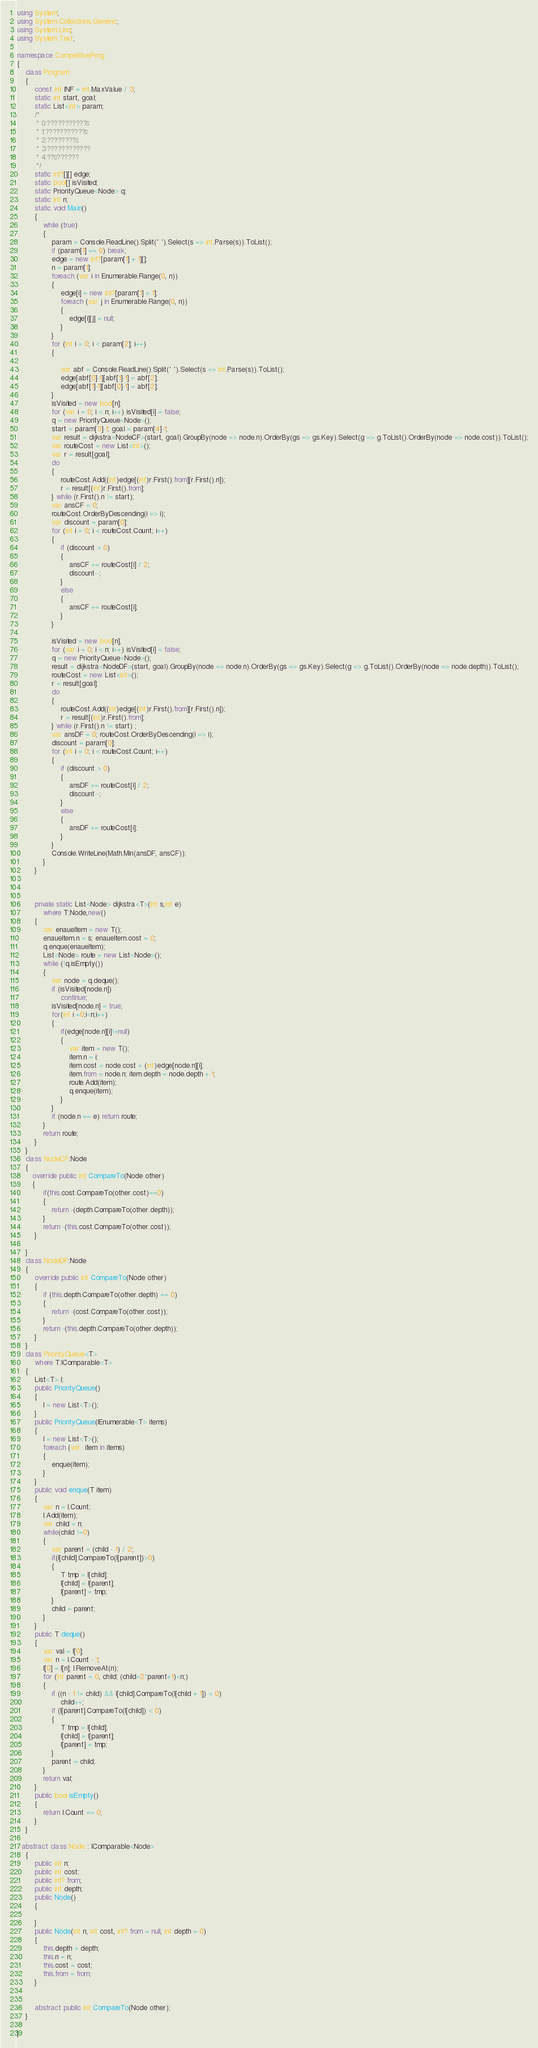<code> <loc_0><loc_0><loc_500><loc_500><_C#_>using System;
using System.Collections.Generic;
using System.Linq;
using System.Text;

namespace CompetitiveProg
{
    class Program
    {
        const int INF = int.MaxValue / 3;
        static int start, goal;
        static List<int> param;
        /*
         * 0:???????????°
         * 1:???????????°
         * 2:????????°
         * 3:????????????
         * 4:??´??????
         */
        static int?[][] edge;
        static bool[] isVisited;
        static PriorityQueue<Node> q;
        static int n;
        static void Main()
        {
            while (true)
            {
                param = Console.ReadLine().Split(' ').Select(s => int.Parse(s)).ToList();
                if (param[1] == 0) break;
                edge = new int?[param[1] + 1][];
                n = param[1];
                foreach (var i in Enumerable.Range(0, n))
                {
                    edge[i] = new int?[param[1] + 1];
                    foreach (var j in Enumerable.Range(0, n))
                    {
                        edge[i][j] = null;
                    }
                }
                for (int i = 0; i < param[2]; i++)
                {

                    var abf = Console.ReadLine().Split(' ').Select(s => int.Parse(s)).ToList();
                    edge[abf[0]-1][abf[1]-1] = abf[2];
                    edge[abf[1]-1][abf[0]-1] = abf[2];
                }
                isVisited = new bool[n];
                for (var i = 0; i < n; i++) isVisited[i] = false;
                q = new PriorityQueue<Node>();
                start = param[3]-1; goal = param[4]-1;
                var result = dijkstra<NodeCF>(start, goal).GroupBy(node => node.n).OrderBy(gs => gs.Key).Select(g => g.ToList().OrderBy(node => node.cost)).ToList();
                var routeCost = new List<int>();
                var r = result[goal];
                do
                {
                    routeCost.Add((int)edge[(int)r.First().from][r.First().n]);
                    r = result[(int)r.First().from];
                } while (r.First().n != start);
                var ansCF = 0; 
                routeCost.OrderByDescending(i => i);
                var discount = param[0];
                for (int i = 0; i < routeCost.Count; i++)
                {
                    if (discount > 0)
                    {
                        ansCF += routeCost[i] / 2;
                        discount--;
                    }
                    else
                    {
                        ansCF += routeCost[i];
                    }
                }

                isVisited = new bool[n];
                for (var i = 0; i < n; i++) isVisited[i] = false;
                q = new PriorityQueue<Node>();
                result = dijkstra<NodeDF>(start, goal).GroupBy(node => node.n).OrderBy(gs => gs.Key).Select(g => g.ToList().OrderBy(node => node.depth)).ToList();
                routeCost = new List<int>();
                r = result[goal];
                do
                {
                    routeCost.Add((int)edge[(int)r.First().from][r.First().n]);
                    r = result[(int)r.First().from];
                } while (r.First().n != start) ;
                var ansDF = 0; routeCost.OrderByDescending(i => i);
                discount = param[0];
                for (int i = 0; i < routeCost.Count; i++)
                {
                    if (discount > 0)
                    {
                        ansDF += routeCost[i] / 2;
                        discount--;
                    }
                    else
                    {
                        ansDF += routeCost[i];
                    }
                }
                Console.WriteLine(Math.Min(ansDF, ansCF));
            }
        }
            


        private static List<Node> dijkstra<T>(int s,int e)
            where T:Node,new()
        {
            var enaueItem = new T();
            enaueItem.n = s; enaueItem.cost = 0;
            q.enque(enaueItem);
            List<Node> route = new List<Node>();
            while (!q.isEmpty())
            {
                var node = q.deque();
                if (isVisited[node.n]) 
                    continue;
                isVisited[node.n] = true;
                for(int i =0;i<n;i++)
                {
                    if(edge[node.n][i]!=null)
                    {
                        var item = new T();
                        item.n = i; 
                        item.cost = node.cost + (int)edge[node.n][i];
                        item.from = node.n; item.depth = node.depth + 1;
                        route.Add(item);
                        q.enque(item);
                    }
                }
                if (node.n == e) return route;
            }
            return route;
        }
    }
    class NodeCF:Node
    {
       override public int CompareTo(Node other)
       {
            if(this.cost.CompareTo(other.cost)==0)
            {
                return -(depth.CompareTo(other.depth));
            }
            return -(this.cost.CompareTo(other.cost));
        }

    }
    class NodeDF:Node
    {
        override public int CompareTo(Node other)
        {
            if (this.depth.CompareTo(other.depth) == 0)
            {
                return -(cost.CompareTo(other.cost));
            }
            return -(this.depth.CompareTo(other.depth));
        }
    }
    class PriorityQueue<T>
        where T:IComparable<T>
    {
        List<T> l;
        public PriorityQueue()
        {
            l = new List<T>();
        }
        public PriorityQueue(IEnumerable<T> items)
        {
            l = new List<T>();
            foreach (var  item in items)
            {
                enque(item);
            }
        }
        public void enque(T item)
        {
            var n = l.Count;
            l.Add(item);
            var child = n;
            while(child !=0)
            {
                var parent = (child - 1) / 2;
                if(l[child].CompareTo(l[parent])>0)
                {
                    T tmp = l[child];
                    l[child] = l[parent];
                    l[parent] = tmp;
                }
                child = parent;
            }
        }
        public T deque()
        {
            var val = l[0];
            var n = l.Count - 1;
            l[0] = l[n]; l.RemoveAt(n);
            for (int parent = 0, child; (child=2*parent+1)<n;)
            {
                if ((n - 1 != child) && l[child].CompareTo(l[child + 1]) < 0)
                    child++;
                if (l[parent].CompareTo(l[child]) < 0)
                {
                    T tmp = l[child];
                    l[child] = l[parent];
                    l[parent] = tmp;
                }
                parent = child;
            }
            return val;
        }
        public bool isEmpty()
        {
            return l.Count == 0;
        }
    }

  abstract class Node : IComparable<Node>
    {
        public int n;
        public int cost;
        public int? from;
        public int depth;
        public Node()
        {

        }
        public Node(int n, int cost, int? from = null, int depth = 0)
        {
            this.depth = depth;
            this.n = n;
            this.cost = cost;
            this.from = from;
        }


        abstract public int CompareTo(Node other);
    }
       
}</code> 